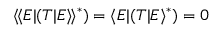Convert formula to latex. <formula><loc_0><loc_0><loc_500><loc_500>\langle \, \langle E | ( T | E \rangle \, \rangle ^ { * } ) = \langle E | ( T | E \rangle ^ { * } ) = 0</formula> 